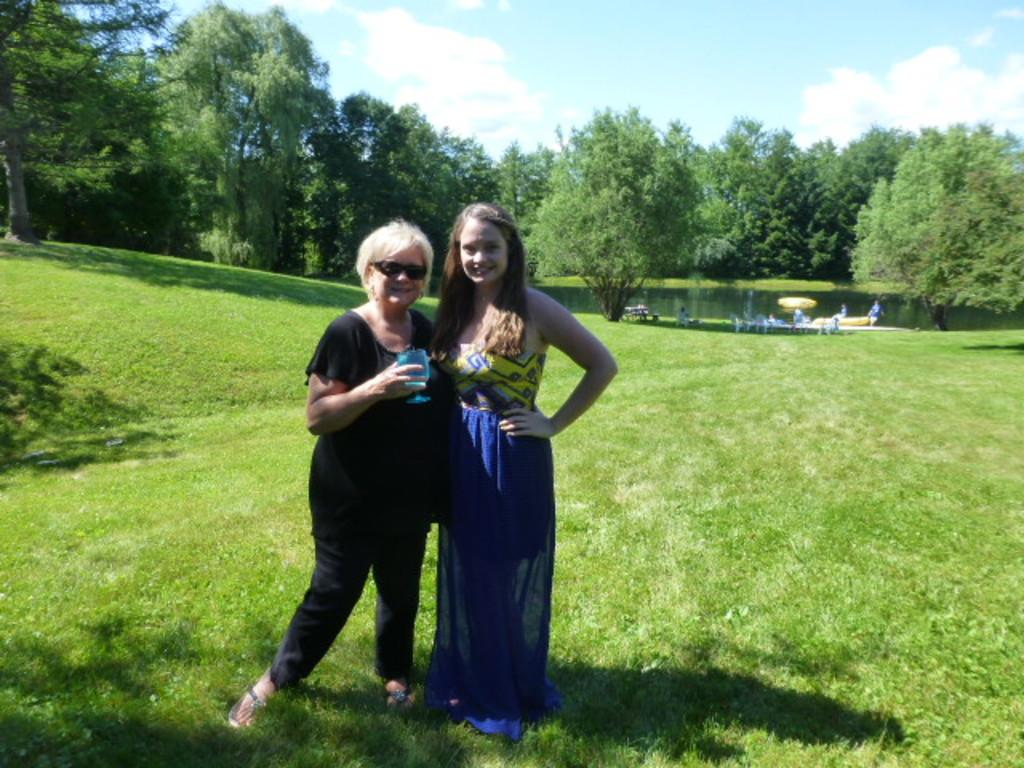How many people are in the image? There are people in the image, specifically two women standing on the grass. What can be seen in the background of the image? In the background of the image, there are chairs, trees, and water visible. What is the surface the women are standing on? The women are standing on the grass. What type of attention is the pipe receiving from the toothpaste in the image? There is no pipe or toothpaste present in the image. 